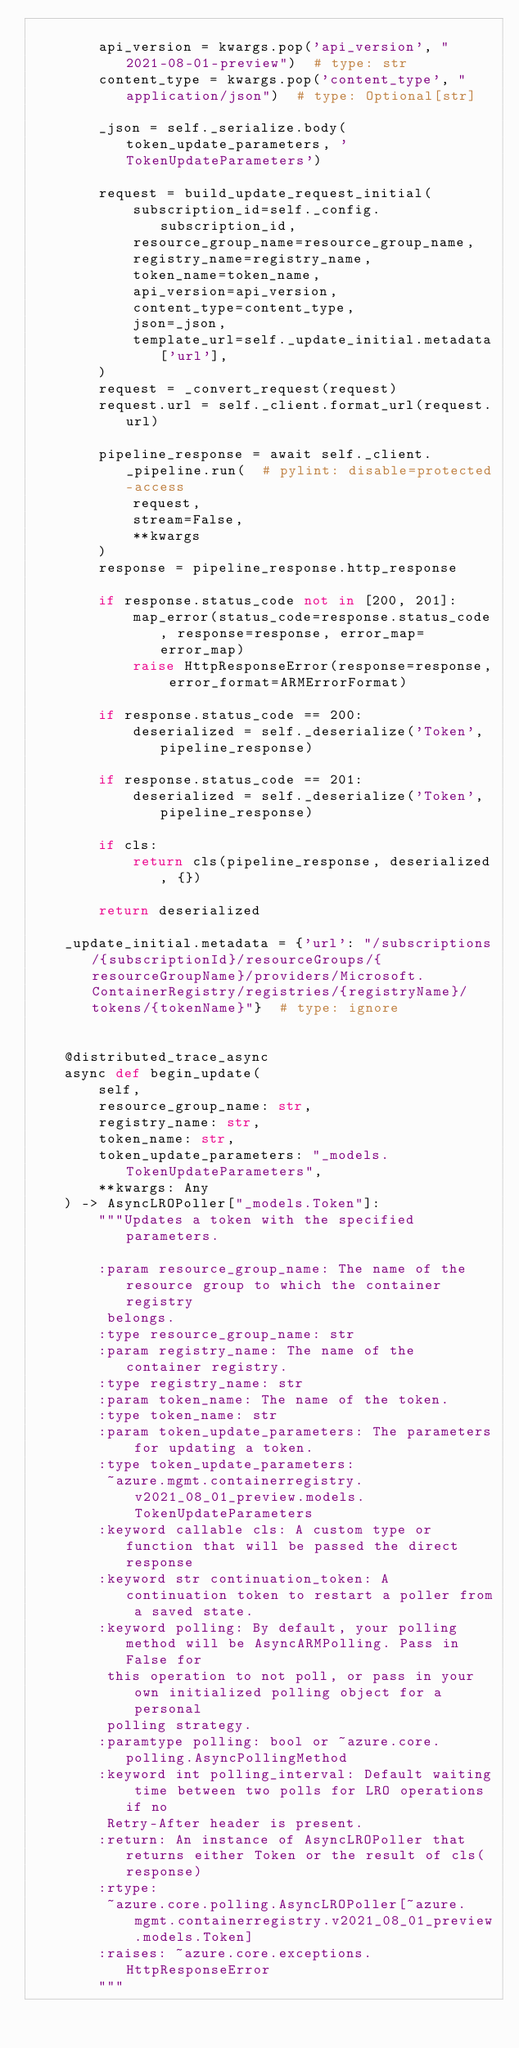Convert code to text. <code><loc_0><loc_0><loc_500><loc_500><_Python_>
        api_version = kwargs.pop('api_version', "2021-08-01-preview")  # type: str
        content_type = kwargs.pop('content_type', "application/json")  # type: Optional[str]

        _json = self._serialize.body(token_update_parameters, 'TokenUpdateParameters')

        request = build_update_request_initial(
            subscription_id=self._config.subscription_id,
            resource_group_name=resource_group_name,
            registry_name=registry_name,
            token_name=token_name,
            api_version=api_version,
            content_type=content_type,
            json=_json,
            template_url=self._update_initial.metadata['url'],
        )
        request = _convert_request(request)
        request.url = self._client.format_url(request.url)

        pipeline_response = await self._client._pipeline.run(  # pylint: disable=protected-access
            request,
            stream=False,
            **kwargs
        )
        response = pipeline_response.http_response

        if response.status_code not in [200, 201]:
            map_error(status_code=response.status_code, response=response, error_map=error_map)
            raise HttpResponseError(response=response, error_format=ARMErrorFormat)

        if response.status_code == 200:
            deserialized = self._deserialize('Token', pipeline_response)

        if response.status_code == 201:
            deserialized = self._deserialize('Token', pipeline_response)

        if cls:
            return cls(pipeline_response, deserialized, {})

        return deserialized

    _update_initial.metadata = {'url': "/subscriptions/{subscriptionId}/resourceGroups/{resourceGroupName}/providers/Microsoft.ContainerRegistry/registries/{registryName}/tokens/{tokenName}"}  # type: ignore


    @distributed_trace_async
    async def begin_update(
        self,
        resource_group_name: str,
        registry_name: str,
        token_name: str,
        token_update_parameters: "_models.TokenUpdateParameters",
        **kwargs: Any
    ) -> AsyncLROPoller["_models.Token"]:
        """Updates a token with the specified parameters.

        :param resource_group_name: The name of the resource group to which the container registry
         belongs.
        :type resource_group_name: str
        :param registry_name: The name of the container registry.
        :type registry_name: str
        :param token_name: The name of the token.
        :type token_name: str
        :param token_update_parameters: The parameters for updating a token.
        :type token_update_parameters:
         ~azure.mgmt.containerregistry.v2021_08_01_preview.models.TokenUpdateParameters
        :keyword callable cls: A custom type or function that will be passed the direct response
        :keyword str continuation_token: A continuation token to restart a poller from a saved state.
        :keyword polling: By default, your polling method will be AsyncARMPolling. Pass in False for
         this operation to not poll, or pass in your own initialized polling object for a personal
         polling strategy.
        :paramtype polling: bool or ~azure.core.polling.AsyncPollingMethod
        :keyword int polling_interval: Default waiting time between two polls for LRO operations if no
         Retry-After header is present.
        :return: An instance of AsyncLROPoller that returns either Token or the result of cls(response)
        :rtype:
         ~azure.core.polling.AsyncLROPoller[~azure.mgmt.containerregistry.v2021_08_01_preview.models.Token]
        :raises: ~azure.core.exceptions.HttpResponseError
        """</code> 